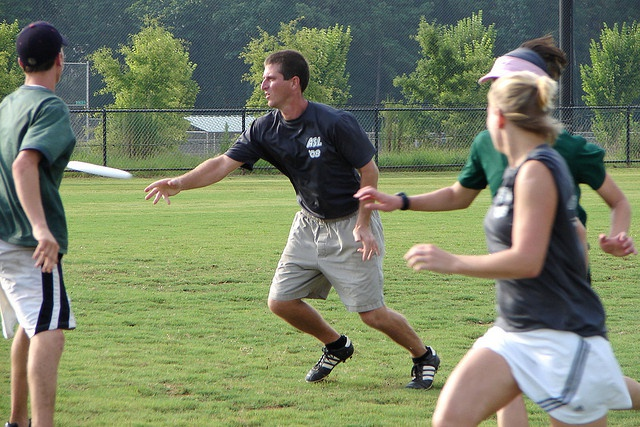Describe the objects in this image and their specific colors. I can see people in purple, black, lightgray, darkgray, and gray tones, people in purple, black, darkgray, and gray tones, people in purple, black, gray, and darkgray tones, people in purple, black, gray, and teal tones, and frisbee in purple, white, darkgray, lightblue, and gray tones in this image. 